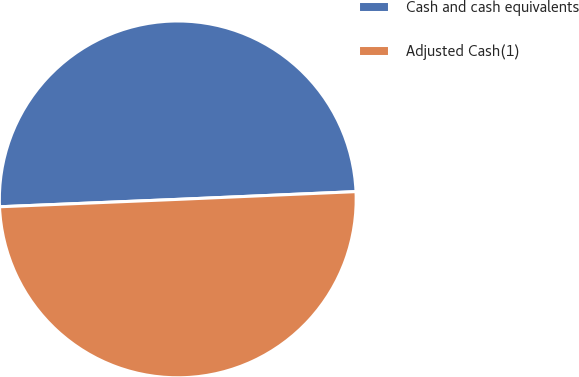Convert chart to OTSL. <chart><loc_0><loc_0><loc_500><loc_500><pie_chart><fcel>Cash and cash equivalents<fcel>Adjusted Cash(1)<nl><fcel>49.97%<fcel>50.03%<nl></chart> 